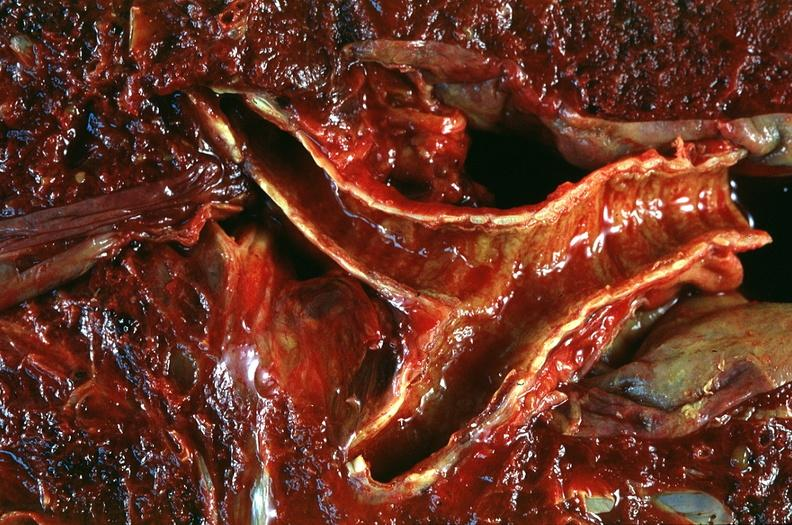what does this image show?
Answer the question using a single word or phrase. Lung 